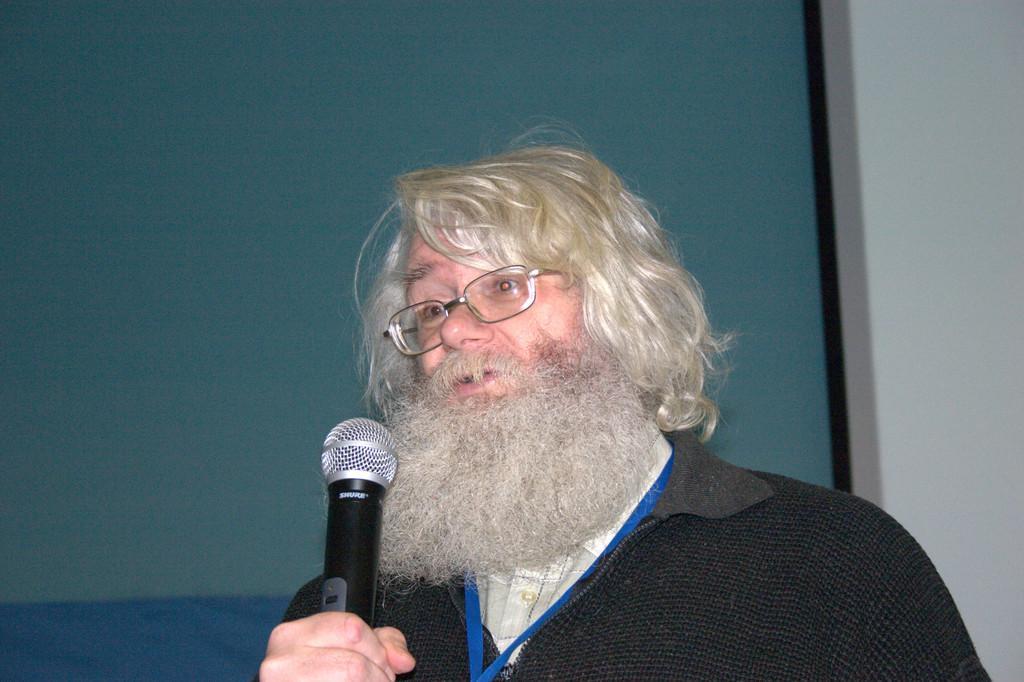In one or two sentences, can you explain what this image depicts? In the center of the image there is a person holding a mic in his hand. In the background of the image there is a green color screen. 